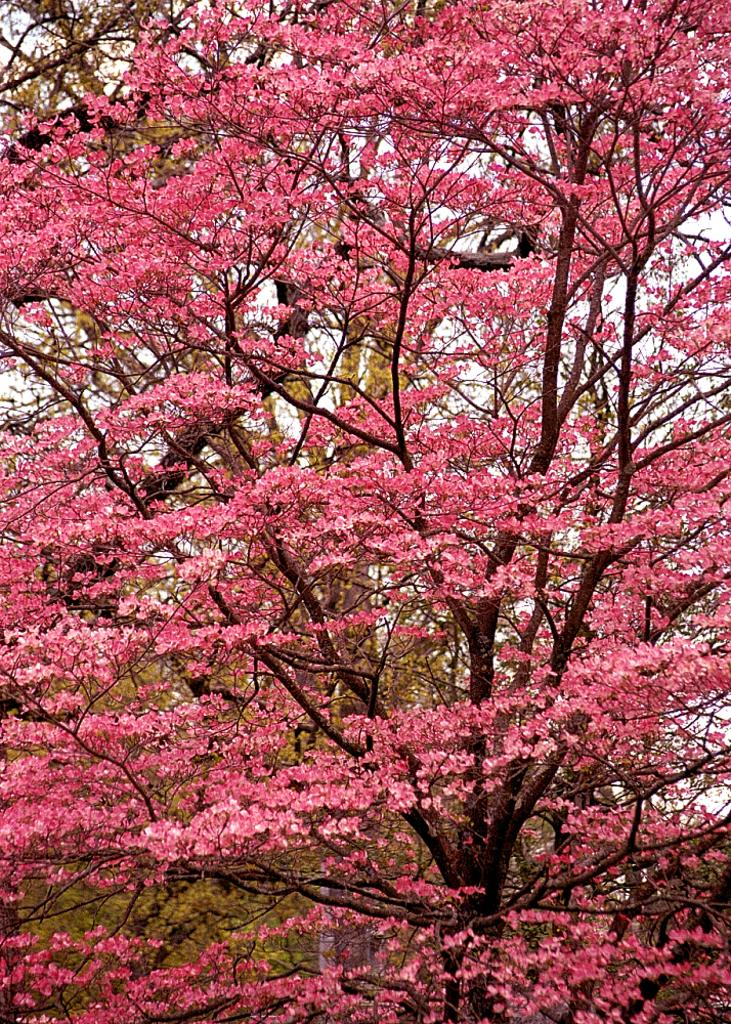What is the main subject of the image? There is a tree in the image. What is unique about the tree? The tree has pink flowers. Are there any other trees in the image? Yes, there are other trees in the background of the image. What can be seen in the sky in the background of the image? Clouds are visible in the sky in the background of the image. How many daughters can be seen playing with the deer in the image? There are no daughters or deer present in the image; it features a tree with pink flowers and other trees in the background. Are there any ants crawling on the tree in the image? There is no indication of ants on the tree in the image. 